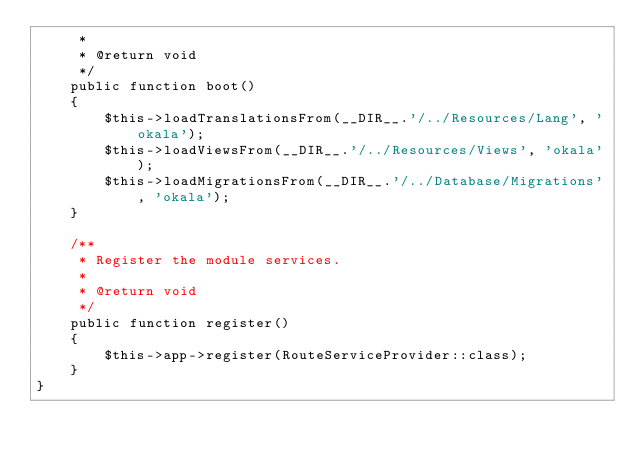Convert code to text. <code><loc_0><loc_0><loc_500><loc_500><_PHP_>     *
     * @return void
     */
    public function boot()
    {
        $this->loadTranslationsFrom(__DIR__.'/../Resources/Lang', 'okala');
        $this->loadViewsFrom(__DIR__.'/../Resources/Views', 'okala');
        $this->loadMigrationsFrom(__DIR__.'/../Database/Migrations', 'okala');
    }

    /**
     * Register the module services.
     *
     * @return void
     */
    public function register()
    {
        $this->app->register(RouteServiceProvider::class);
    }
}
</code> 